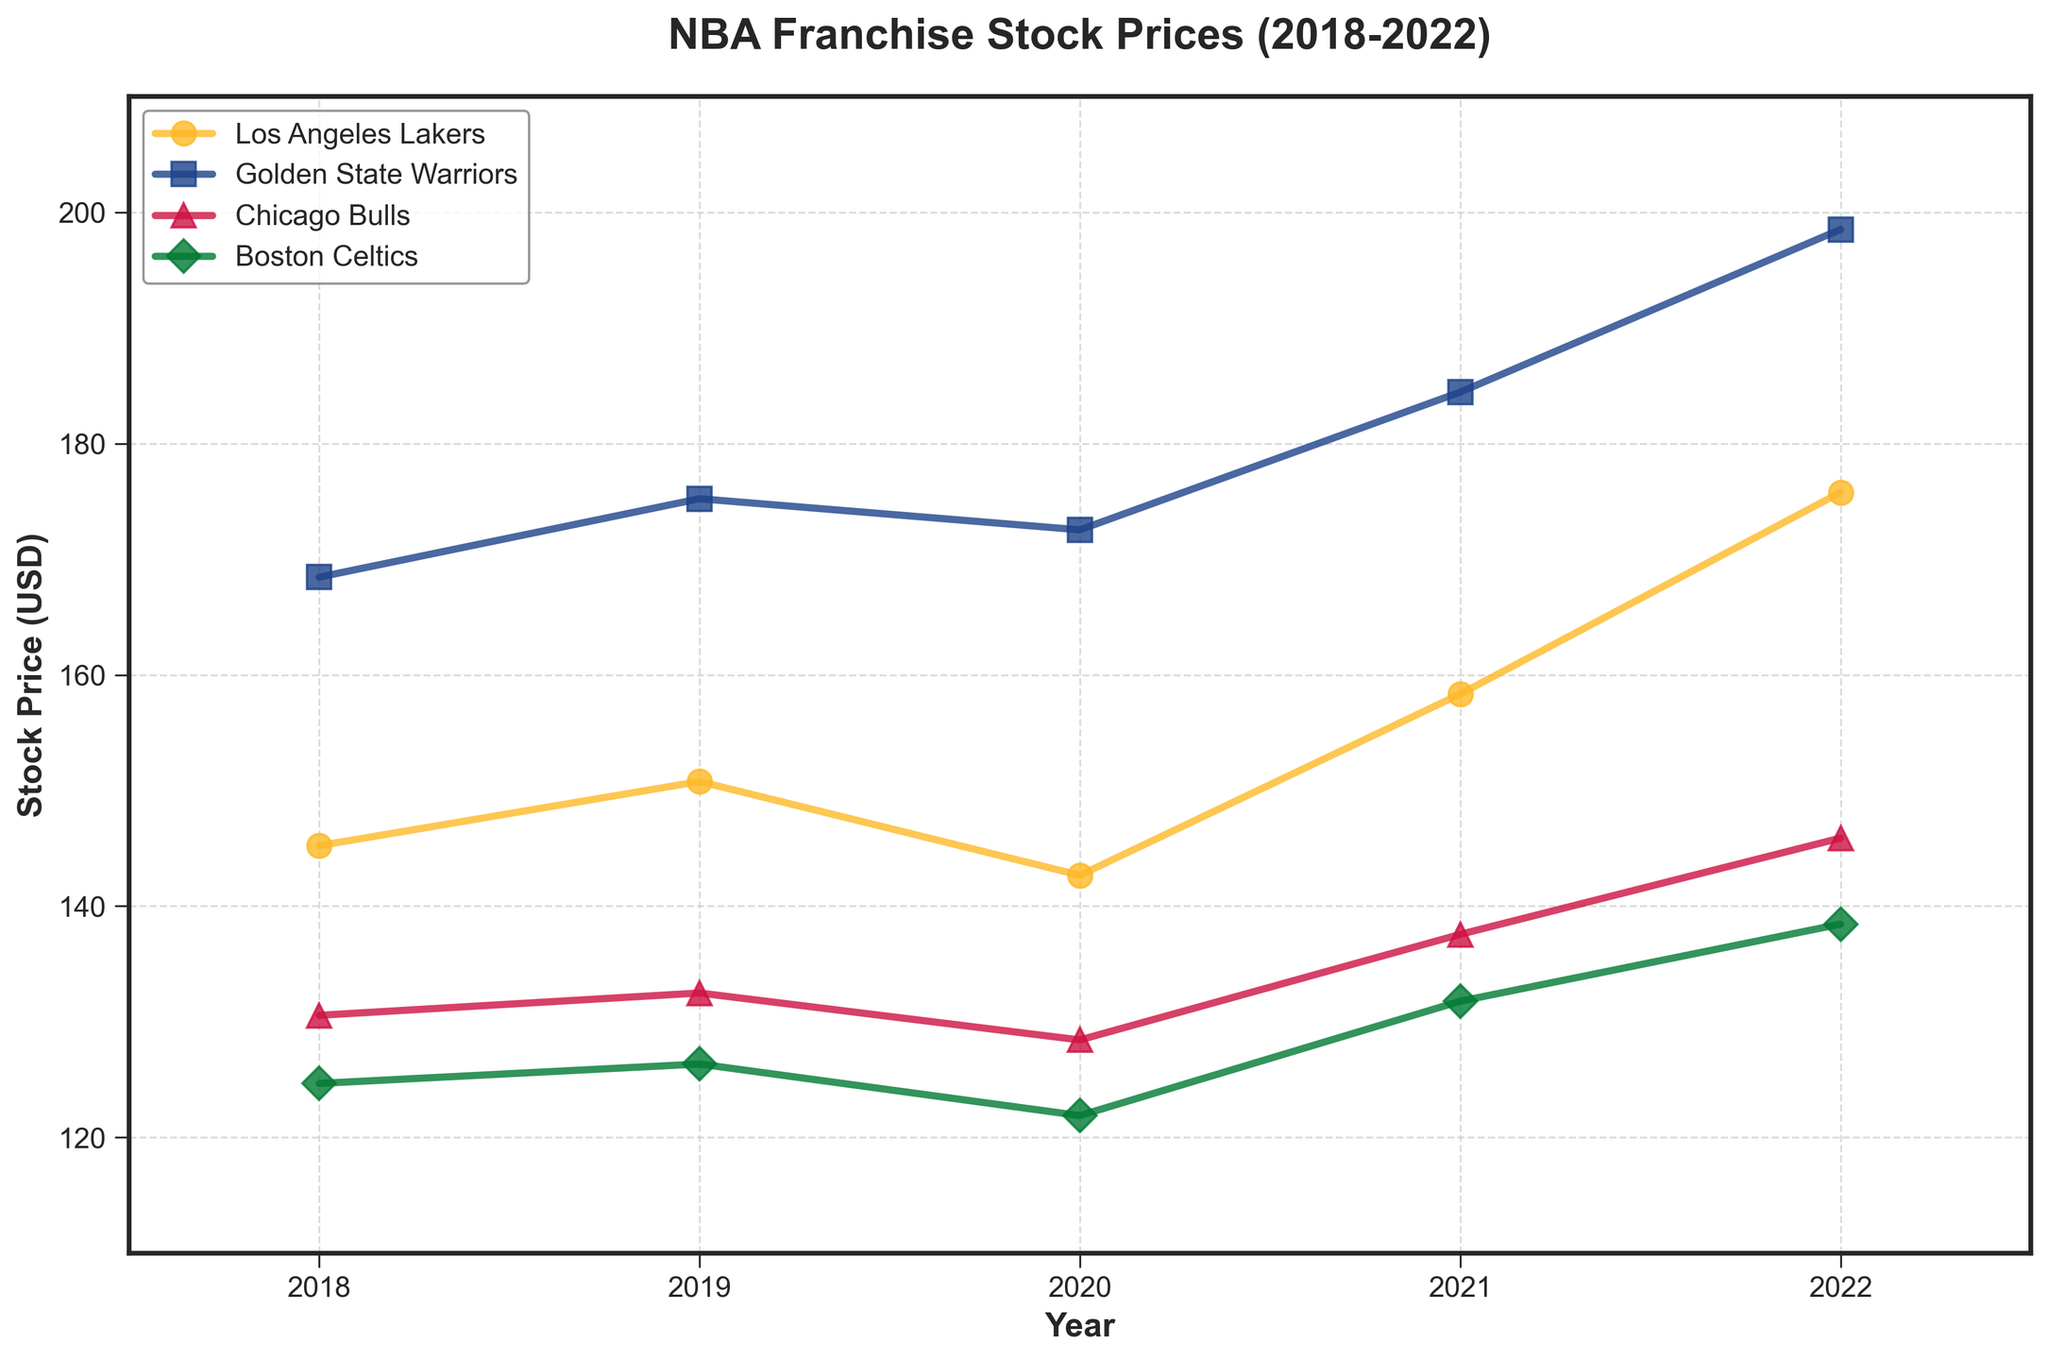What's the title of the plot? The title of the plot is typically found at the top center of the figure. The title for this plot, based on the code provided, is "NBA Franchise Stock Prices (2018-2022)."
Answer: NBA Franchise Stock Prices (2018-2022) How many teams are plotted in the figure? To determine the number of teams, look at the legend of the plot, where each team is represented by a different color and marker. There are four teams listed: Los Angeles Lakers, Golden State Warriors, Chicago Bulls, and Boston Celtics.
Answer: 4 Which team had the highest stock price in 2022? Locate the year 2022 on the x-axis and check the stock price values for each team. The team with the highest value in 2022 is the Golden State Warriors, as their line reaches the highest point.
Answer: Golden State Warriors By how much did the stock price for Los Angeles Lakers increase from 2020 to 2022? For Los Angeles Lakers, find the stock price in 2020 (142.67 USD) and in 2022 (175.78 USD). The increase is calculated by subtracting the 2020 value from the 2022 value: 175.78 - 142.67.
Answer: 33.11 USD What's the average stock price of the Boston Celtics over the given years? Find the stock prices for the Boston Celtics for each year: 124.67 (2018), 126.35 (2019), 121.89 (2020), 131.78 (2021), and 138.45 (2022). Sum these values and divide by the number of years (5). The result is (124.67 + 126.35 + 121.89 + 131.78 + 138.45) / 5.
Answer: 128.63 USD Which year had the highest average stock price across all teams? Average the stock prices for all teams for each year:
2018: (145.23 + 168.45 + 130.56 + 124.67) / 4
2019: (150.78 + 175.23 + 132.49 + 126.35) / 4
2020: (142.67 + 172.54 + 128.43 + 121.89) / 4
2021: (158.34 + 184.45 + 137.56 + 131.78) / 4
2022: (175.78 + 198.52 + 145.89 + 138.45) / 4
Calculate each average and compare. The highest average is for 2022.
Answer: 2022 Did the Chicago Bulls ever experience a decrease in stock price year-over-year during the period shown? Look at the Chicago Bulls' stock prices for each year:
2018: 130.56, 2019: 132.49, 2020: 128.43, 2021: 137.56, 2022: 145.89.
From 2019 to 2020, the stock price decreased from 132.49 to 128.43.
Answer: Yes Which team showed the most consistent (steady) growth in stock price over the years? Look for the team with the least fluctuation and a steady upwards trend. The Golden State Warriors show consistent growth from 2018 (168.45) to 2022 (198.52) with no year showing a decrease.
Answer: Golden State Warriors How much did the stock price for the Boston Celtics change from 2019 to 2020? Find the stock prices for the Boston Celtics in 2019 (126.35) and in 2020 (121.89). Calculate the change: 126.35 - 121.89.
Answer: 4.46 USD 